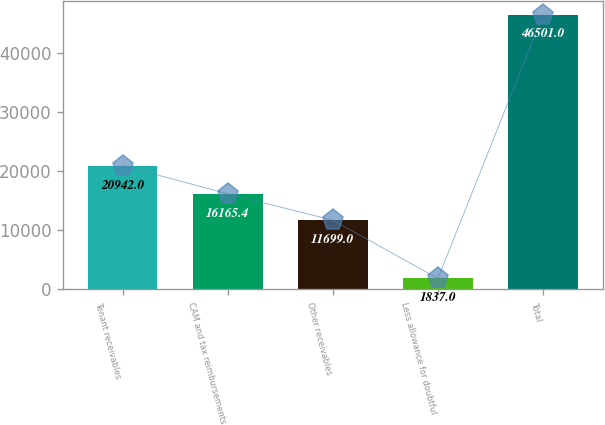<chart> <loc_0><loc_0><loc_500><loc_500><bar_chart><fcel>Tenant receivables<fcel>CAM and tax reimbursements<fcel>Other receivables<fcel>Less allowance for doubtful<fcel>Total<nl><fcel>20942<fcel>16165.4<fcel>11699<fcel>1837<fcel>46501<nl></chart> 